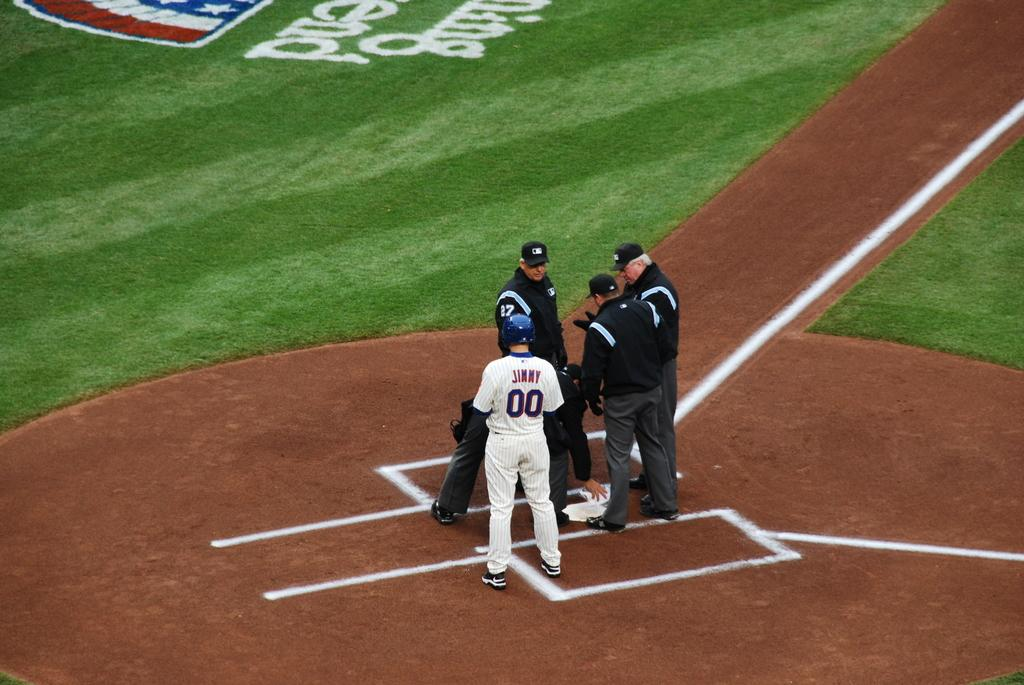<image>
Offer a succinct explanation of the picture presented. the baseball player number 00 is standing with the refs 